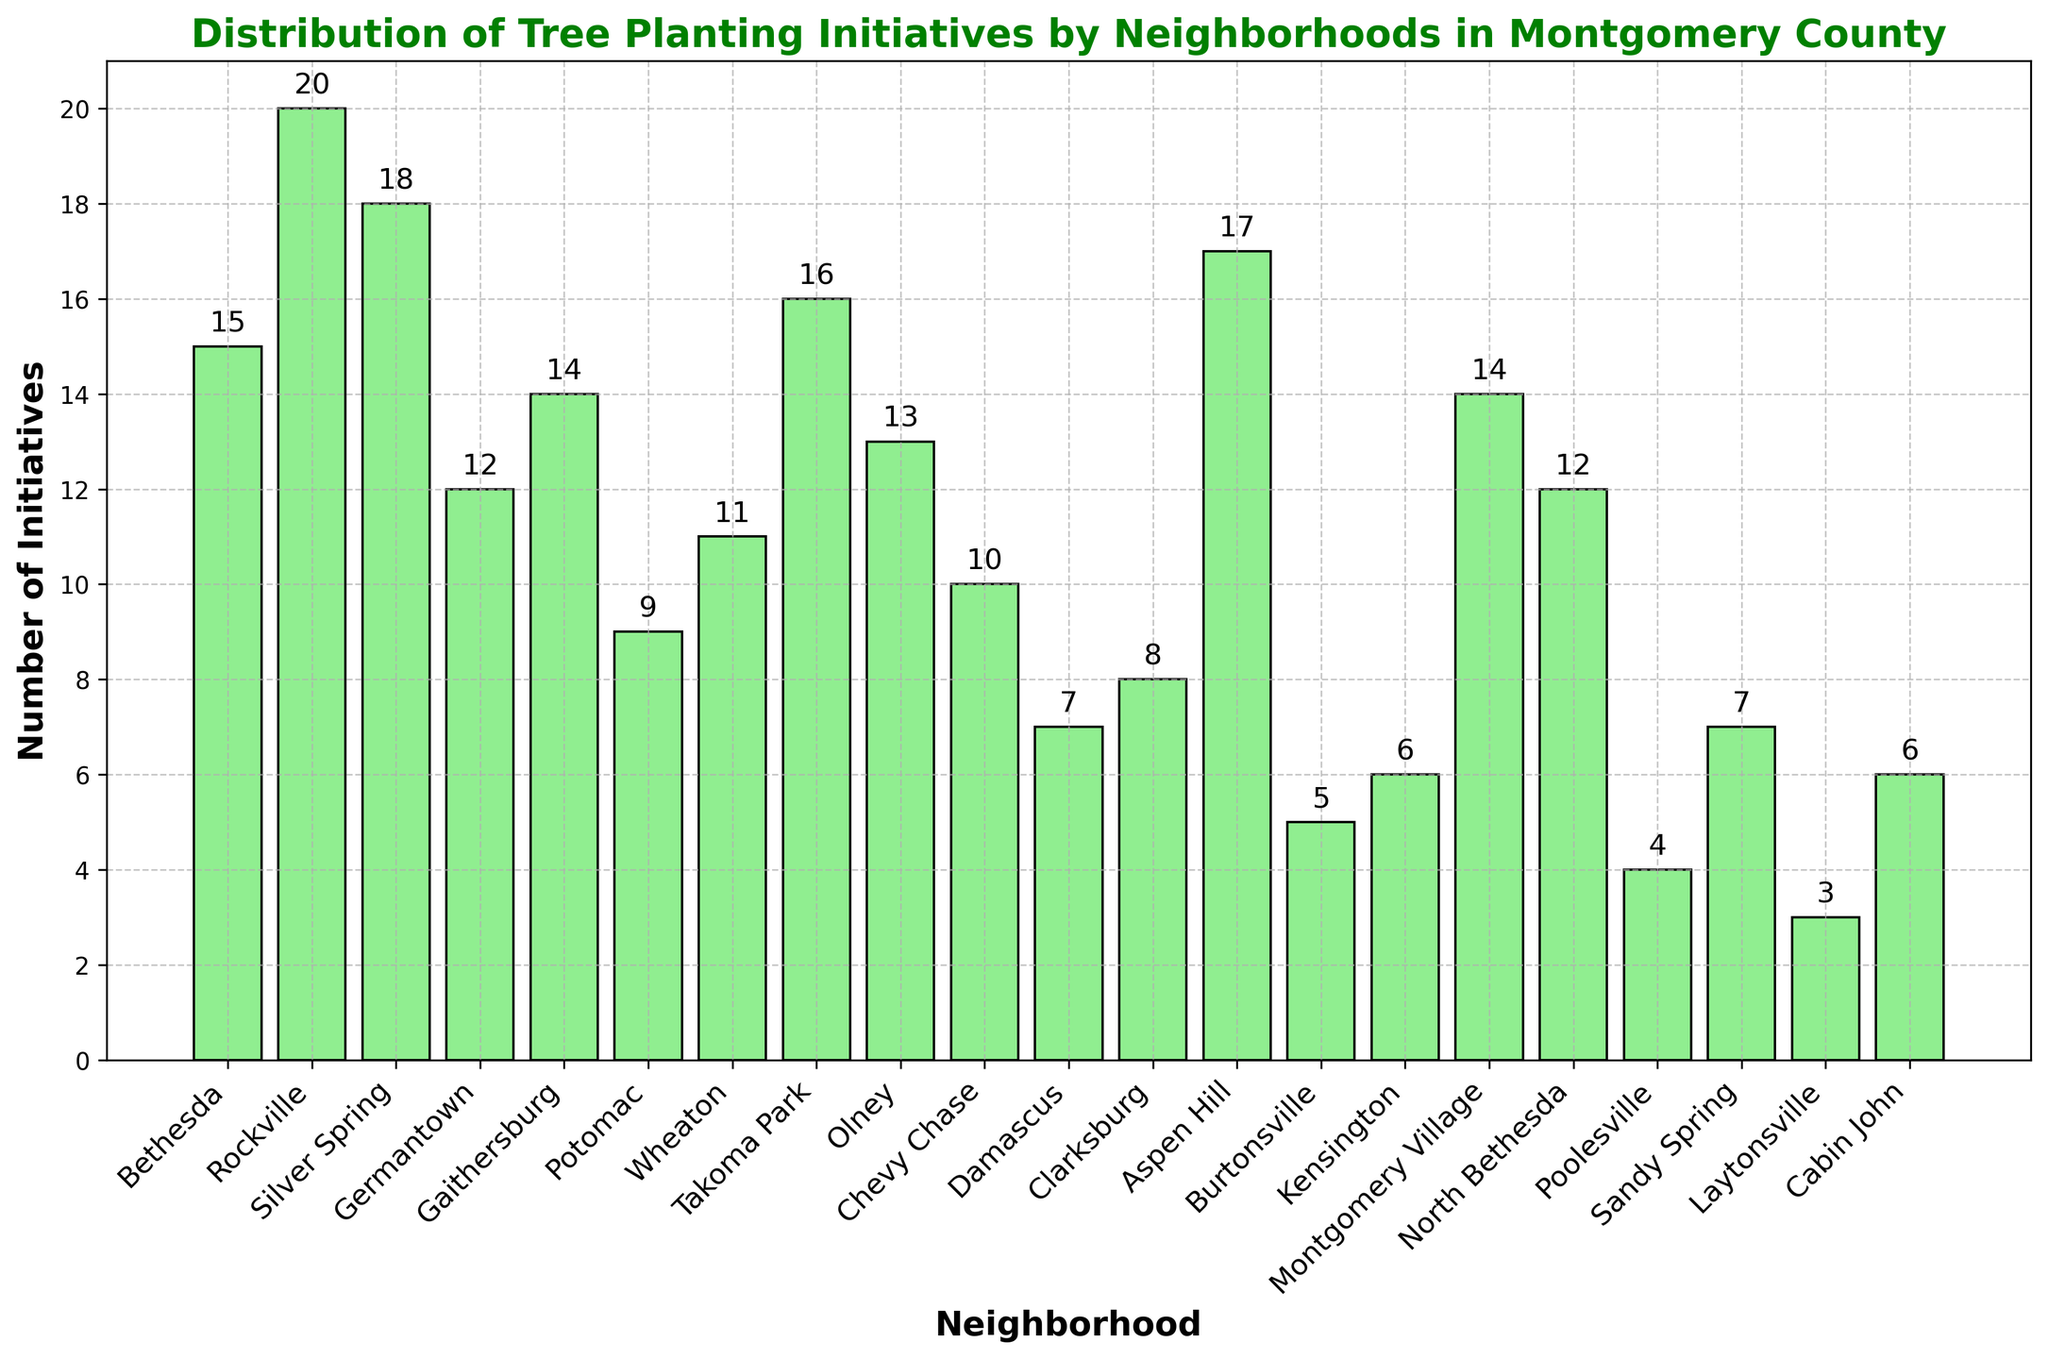What's the neighborhood with the highest number of tree planting initiatives? By looking at the height of the bars, the tallest bar corresponds to Rockville with the highest number of tree planting initiatives.
Answer: Rockville What's the total number of tree planting initiatives across all neighborhoods? Sum the height of all the bars: 15 (Bethesda) + 20 (Rockville) + 18 (Silver Spring) + 12 (Germantown) + 14 (Gaithersburg) + 9 (Potomac) + 11 (Wheaton) + 16 (Takoma Park) + 13 (Olney) + 10 (Chevy Chase) + 7 (Damascus) + 8 (Clarksburg) + 17 (Aspen Hill) + 5 (Burtonsville) + 6 (Kensington) + 14 (Montgomery Village) + 12 (North Bethesda) + 4 (Poolesville) + 7 (Sandy Spring) + 3 (Laytonsville) + 6 (Cabin John)
Answer: 217 What are the neighborhoods with the least number of tree planting initiatives? The shortest bars represent the lowest numbers, which are Laytonsville (3) and Poolesville (4).
Answer: Laytonsville, Poolesville Are there more tree planting initiatives in Aspen Hill or in Takoma Park? By comparing the height of the bars for Aspen Hill and Takoma Park, Aspen Hill has 17 while Takoma Park has 16.
Answer: Aspen Hill Which neighborhoods have exactly 12 tree planting initiatives? Find the bars with a height of 12, which corresponds to Germantown and North Bethesda.
Answer: Germantown, North Bethesda What's the average number of tree planting initiatives per neighborhood? Calculate the sum of all initiatives (217) and divide by the number of neighborhoods (21). So, divide 217 by 21.
Answer: 10.33 (rounded) List the neighborhoods with more than 15 tree planting initiatives. Look for bars higher than 15: Rockville (20), Silver Spring (18), Takoma Park (16), and Aspen Hill (17).
Answer: Rockville, Silver Spring, Takoma Park, Aspen Hill What's the difference in the number of tree planting initiatives between Gaithersburg and Poolesville? Subtract the number of initiatives in Poolesville (4) from the number in Gaithersburg (14).
Answer: 10 How many neighborhoods have fewer than 10 tree planting initiatives? Count the bars with heights less than 10: Potomac (9), Damascus (7), Clarksburg (8), Burtonsville (5), Kensington (6), Poolesville (4), Sandy Spring (7), Laytonsville (3), Cabin John (6).
Answer: 9 Compare the combined initiatives of Wheaton and Olney with those of Rockville. Which is greater? Sum the initiatives for Wheaton (11) and Olney (13) to get 24, compare with Rockville which has 20.
Answer: Wheaton and Olney combined 